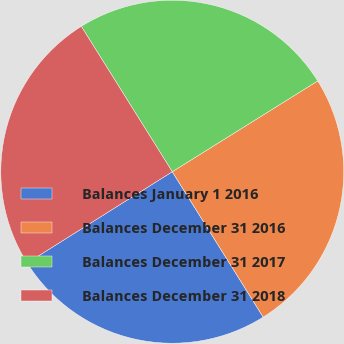<chart> <loc_0><loc_0><loc_500><loc_500><pie_chart><fcel>Balances January 1 2016<fcel>Balances December 31 2016<fcel>Balances December 31 2017<fcel>Balances December 31 2018<nl><fcel>24.96%<fcel>24.99%<fcel>25.02%<fcel>25.04%<nl></chart> 